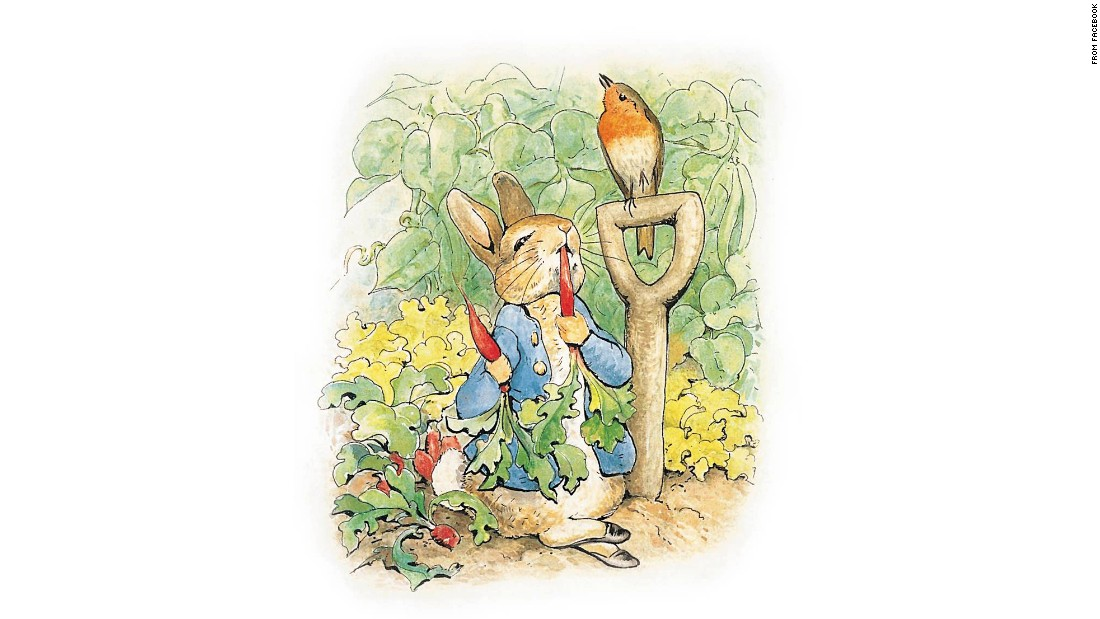What can the presence of the bird in the image tell us about the garden ecosystem? The presence of the bird, likely a robin, in the garden adds an interesting layer to the ecosystem. Birds such as robins are attracted to gardens that are rich in resources. This includes a variety of insects and worms, which are crucial for their diet. Their presence often indicates a healthy, biodiverse environment where the balance of flora and fauna supports various wildlife species. How do birds contribute to the health of a garden? Birds contribute significantly to the health of a garden by aiding in pest control, as they feed on insects that might otherwise damage the plants. Additionally, birds help in pollination and seed dispersal, enhancing plant diversity and growth. Their activity helps maintain a dynamic ecological balance, encouraging a robust garden ecosystem. 